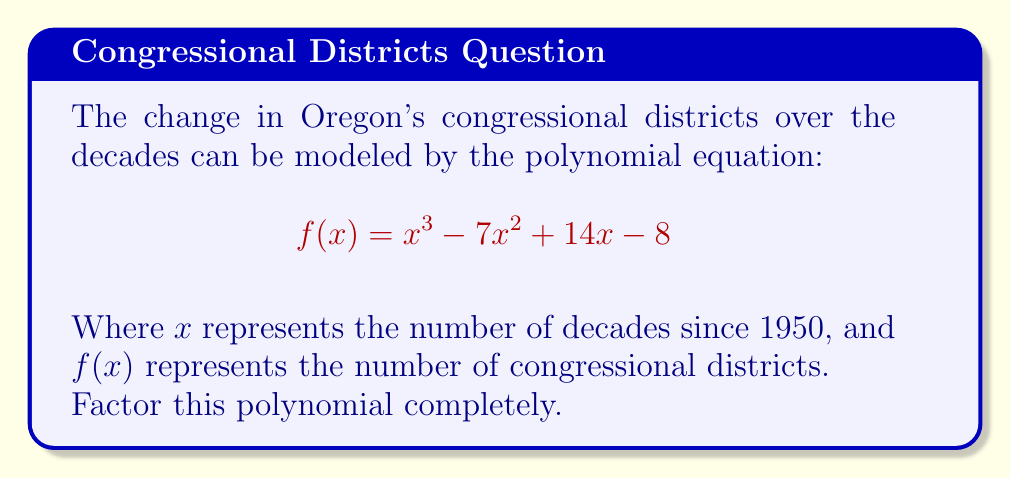Solve this math problem. To factor this polynomial, we'll follow these steps:

1) First, let's check if there are any rational roots using the rational root theorem. The possible rational roots are the factors of the constant term: ±1, ±2, ±4, ±8.

2) Testing these values, we find that $f(1) = 0$. So $(x-1)$ is a factor.

3) We can use polynomial long division to divide $f(x)$ by $(x-1)$:

   $$x^3 - 7x^2 + 14x - 8 = (x-1)(x^2 - 6x + 8)$$

4) Now we need to factor the quadratic $x^2 - 6x + 8$. We can do this by finding two numbers that multiply to give 8 and add to give -6. These numbers are -2 and -4.

5) So, $x^2 - 6x + 8 = (x-2)(x-4)$

6) Putting it all together:

   $$f(x) = x^3 - 7x^2 + 14x - 8 = (x-1)(x-2)(x-4)$$

This factorization represents the historical changes in Oregon's congressional districts. Each factor $(x-n)$ corresponds to a change that occurred $n$ decades after 1950. For a historian of Oregon's political history, this could indicate significant redistricting events in 1960, 1970, and 1990.
Answer: $f(x) = (x-1)(x-2)(x-4)$ 